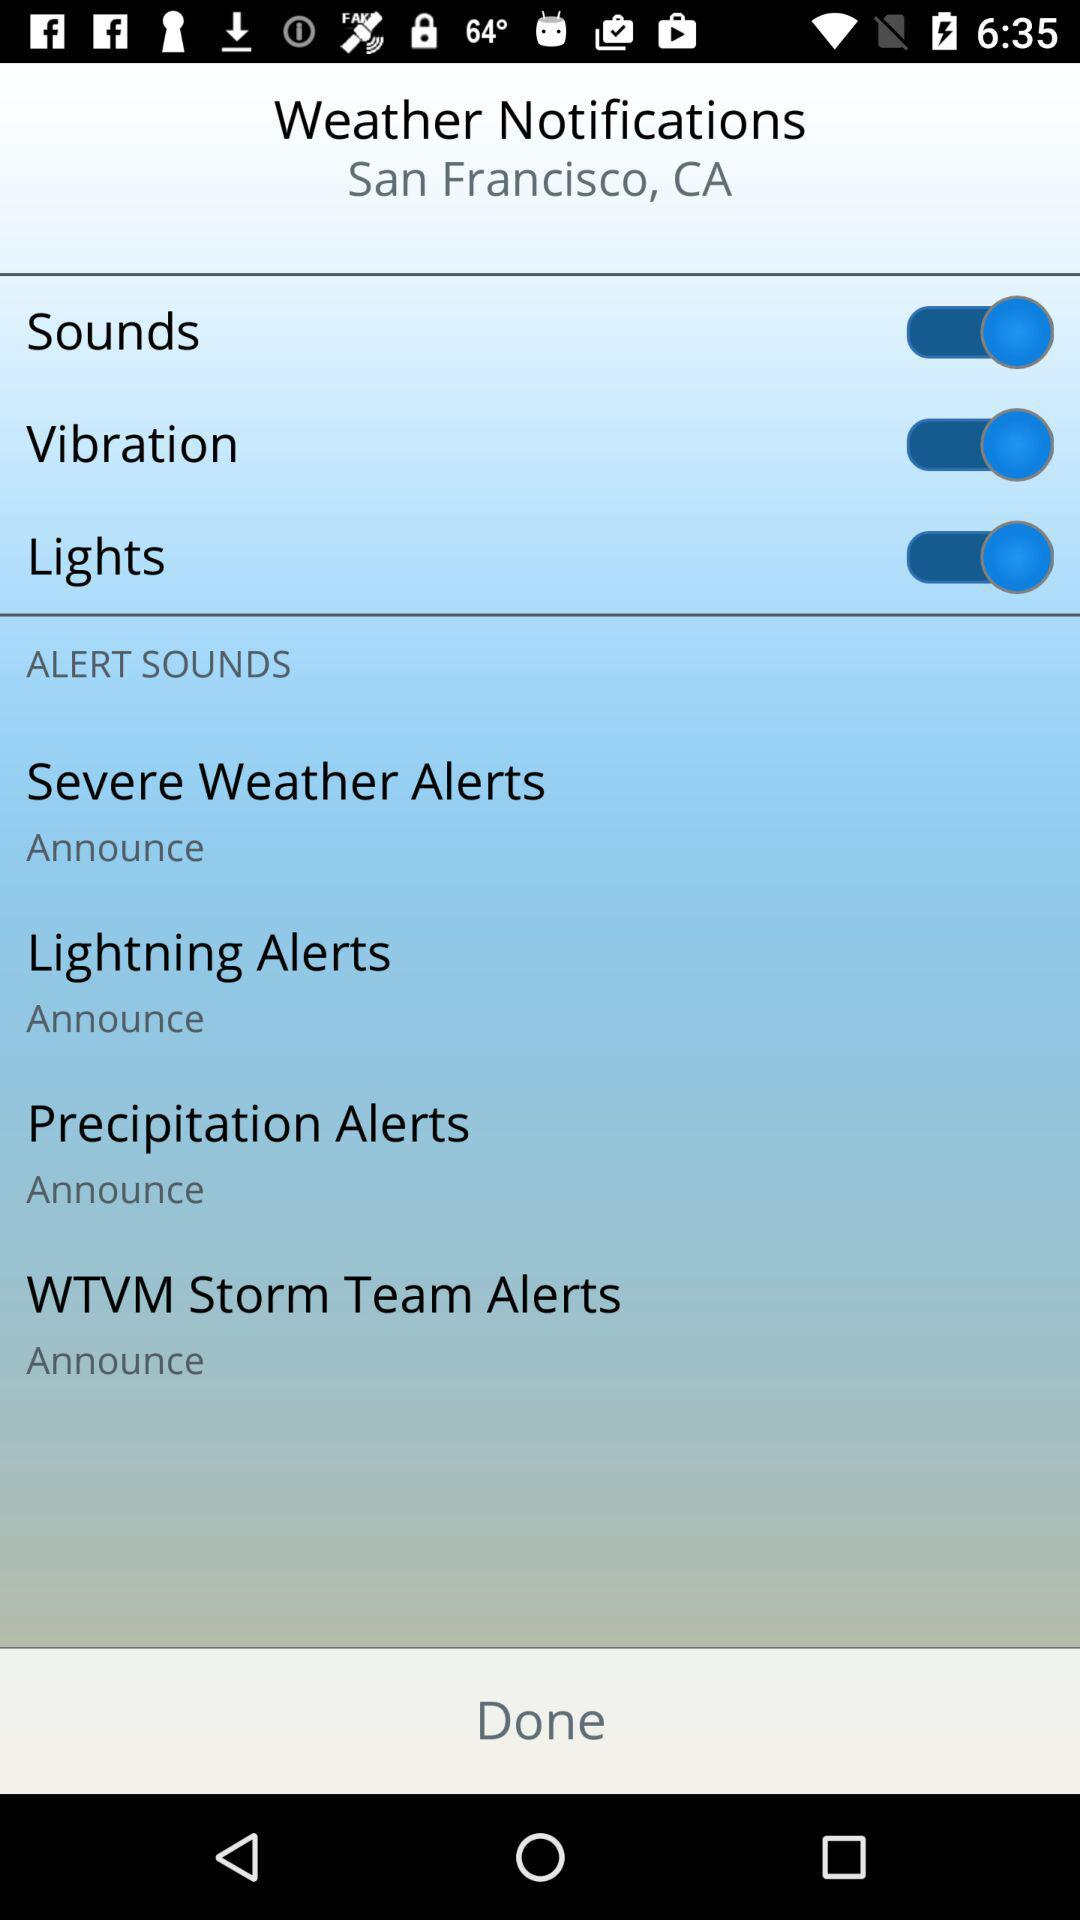What's the mentioned place for weather alerts? The mentioned place is San Francisco, CA. 